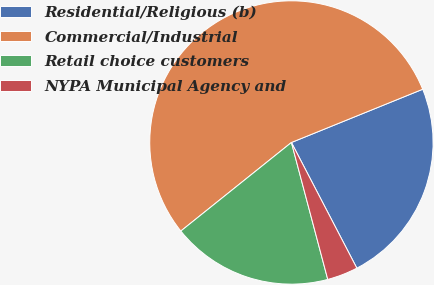Convert chart to OTSL. <chart><loc_0><loc_0><loc_500><loc_500><pie_chart><fcel>Residential/Religious (b)<fcel>Commercial/Industrial<fcel>Retail choice customers<fcel>NYPA Municipal Agency and<nl><fcel>23.49%<fcel>54.61%<fcel>18.38%<fcel>3.51%<nl></chart> 